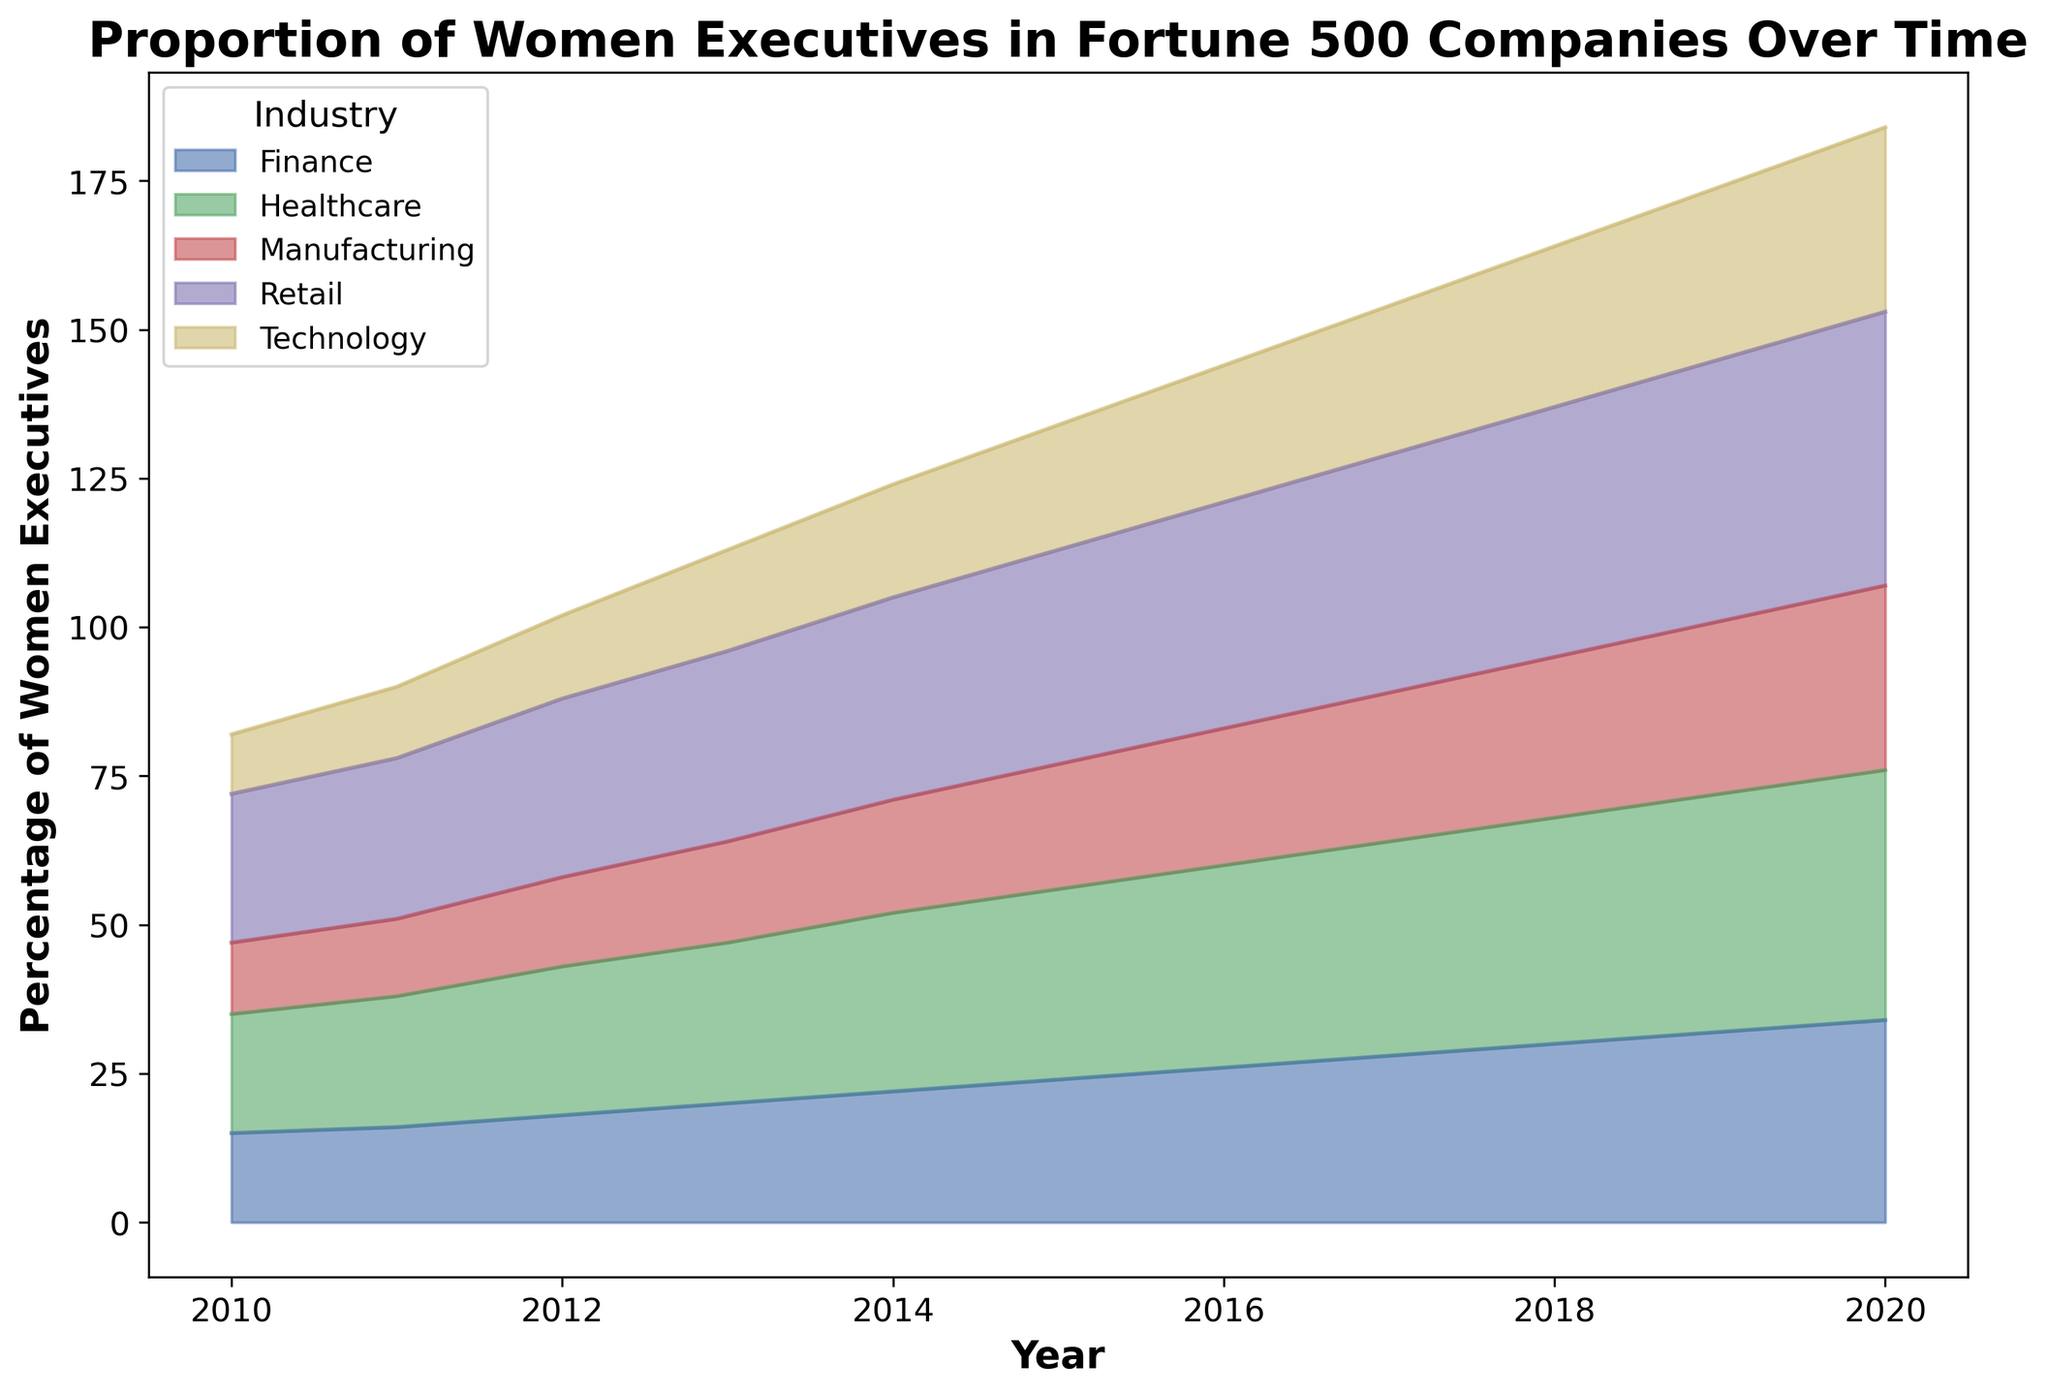What industry had the highest proportion of women executives in 2020? By observing the end of the chart for the year 2020, the industry with the topmost area segment corresponds to Retail.
Answer: Retail Which industry sector showed the largest increase in the proportion of women executives from 2010 to 2020? To find the sector with the largest increase, compare the starting height in 2010 and the ending height in 2020 for each area. The increase is visibly greatest for the Healthcare sector.
Answer: Healthcare Between 2015 and 2018, which industry showed a consistent increase every year? By comparing the heights of each industry section from each year between 2015 and 2018, the sections for each year show a consistent increase for the Technology sector.
Answer: Technology What is the total increase in the proportion of women executives in the Finance industry from 2010 to 2020? Subtract the percentage of women executives in Finance in 2010 (15%) from the percentage in 2020 (34%). The difference is 34% - 15% = 19%.
Answer: 19% Which two industries had the most similar proportion of women executives in 2015? In 2015, visually compare the heights of the sections for each industry. The Manufacturing and Technology sectors had very similar heights, close to 21% and 21% respectively.
Answer: Manufacturing and Technology In 2016, which industry had a smaller proportion of women executives than Healthcare but larger than Technology? By comparing the section heights in 2016, Finance had a smaller proportion than Healthcare but larger than Technology.
Answer: Finance What was the average proportion of women executives in the Retail sector across the decade? Add each year's percentage for Retail (25 + 27 + 30 + 32 + 34 + 36 + 38 + 40 + 42 + 44 + 46) and divide by 11 (number of years). The average is (394 / 11) ≈ 35.82%.
Answer: 35.82% During which two consecutive years did the Manufacturing sector show the largest increase in women executives? Compare year-over-year changes in the Manufacturing sector. The largest increase was between 2012 (15%) and 2013 (17%), a difference of 2%.
Answer: 2012-2013 From the visual characteristics of the plot, which industry is typically represented by the largest area? The area with the largest height consistently throughout the years is Retail, indicating it typically has the largest area.
Answer: Retail 